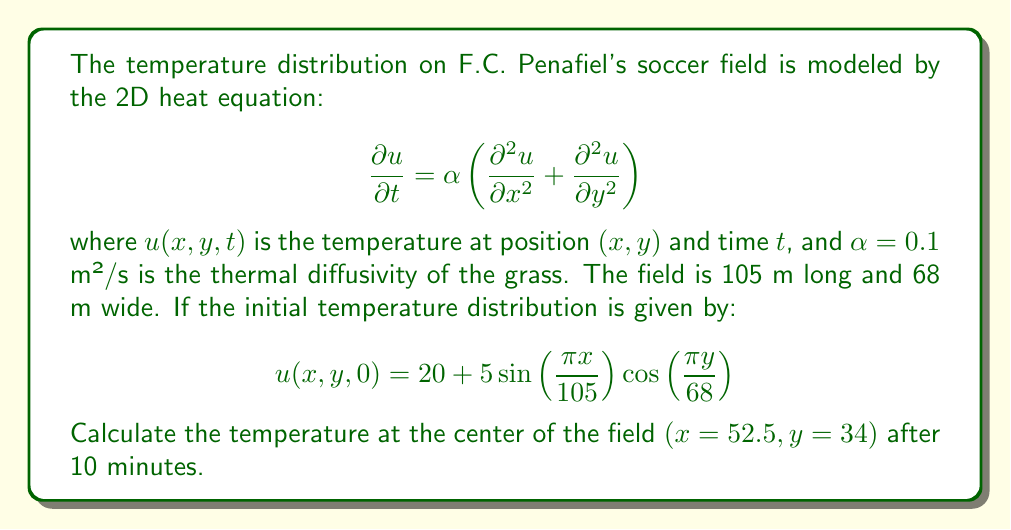Give your solution to this math problem. To solve this problem, we'll use the method of separation of variables:

1) Assume a solution of the form: $u(x,y,t) = X(x)Y(y)T(t)$

2) Substituting this into the heat equation and separating variables, we get:

   $$\frac{T'(t)}{αT(t)} = \frac{X''(x)}{X(x)} + \frac{Y''(y)}{Y(y)} = -k^2$$

   where $k^2$ is a separation constant.

3) This leads to three ODEs:
   
   $$T'(t) + αk^2T(t) = 0$$
   $$X''(x) + λ^2X(x) = 0$$
   $$Y''(y) + μ^2Y(y) = 0$$

   where $k^2 = λ^2 + μ^2$

4) The general solution is:

   $$u(x,y,t) = \sum_{n=1}^{\infty}\sum_{m=1}^{\infty} A_{nm} \sin\left(\frac{nπx}{105}\right)\cos\left(\frac{mπy}{68}\right)e^{-α((\frac{nπ}{105})^2+(\frac{mπ}{68})^2)t}$$

5) Comparing with the initial condition, we see that only the term with $n=1$ and $m=1$ is non-zero, with $A_{11} = 5$. The constant term 20 can be added separately.

6) Therefore, the solution is:

   $$u(x,y,t) = 20 + 5\sin\left(\frac{πx}{105}\right)\cos\left(\frac{πy}{68}\right)e^{-α((\frac{π}{105})^2+(\frac{π}{68})^2)t}$$

7) At the center of the field $(x=52.5, y=34)$ after 10 minutes $(t=600s)$:

   $$u(52.5,34,600) = 20 + 5\sin\left(\frac{π}{2}\right)\cos\left(\frac{π}{2}\right)e^{-0.1((\frac{π}{105})^2+(\frac{π}{68})^2)600}$$

8) Simplify:
   $$u(52.5,34,600) = 20 + 5e^{-0.1((\frac{π}{105})^2+(\frac{π}{68})^2)600} \approx 24.81°C$$
Answer: 24.81°C 